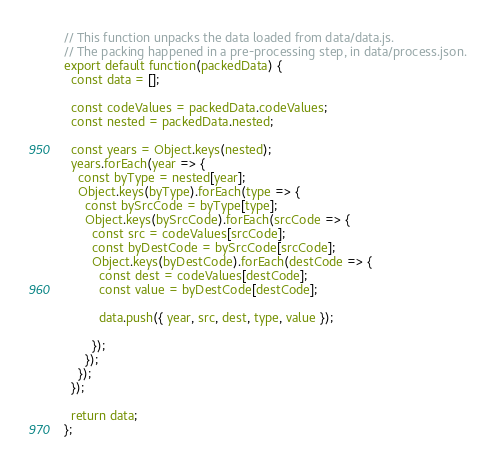Convert code to text. <code><loc_0><loc_0><loc_500><loc_500><_JavaScript_>// This function unpacks the data loaded from data/data.js.
// The packing happened in a pre-processing step, in data/process.json.
export default function(packedData) {
  const data = [];

  const codeValues = packedData.codeValues;
  const nested = packedData.nested;

  const years = Object.keys(nested);
  years.forEach(year => {
    const byType = nested[year];
    Object.keys(byType).forEach(type => {
      const bySrcCode = byType[type];
      Object.keys(bySrcCode).forEach(srcCode => {
        const src = codeValues[srcCode];
        const byDestCode = bySrcCode[srcCode];
        Object.keys(byDestCode).forEach(destCode => {
          const dest = codeValues[destCode];
          const value = byDestCode[destCode];

          data.push({ year, src, dest, type, value });

        });
      });
    });
  });

  return data;
};
</code> 